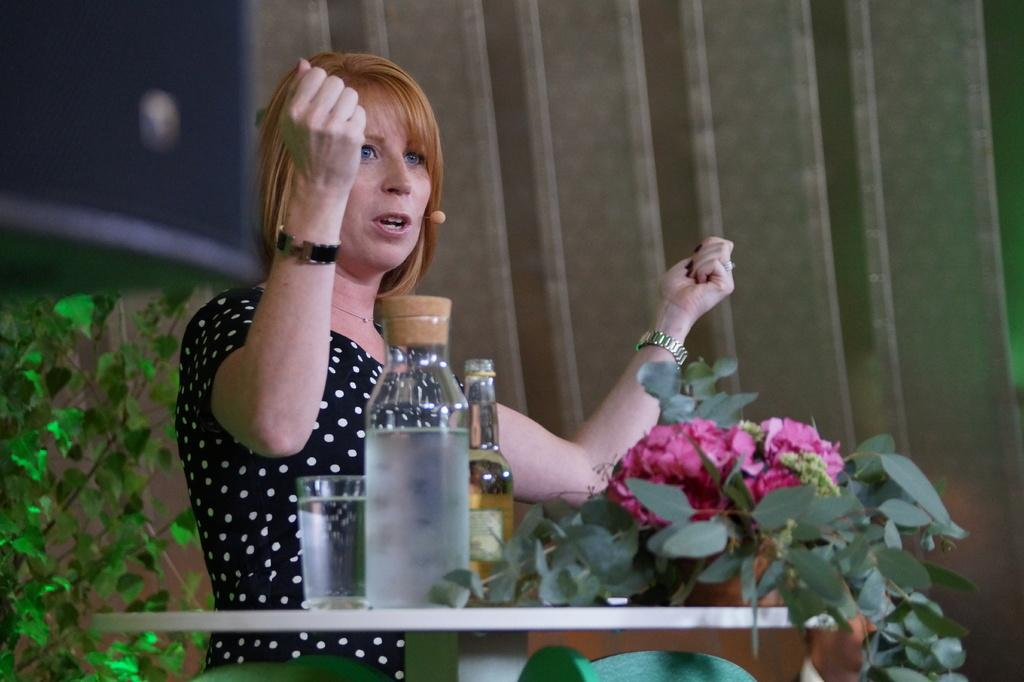Who is the main subject in the image? There is a woman in the image. What is the woman doing in the image? The woman is standing and talking in front of a mic. What objects can be seen on the table in the image? There are bottles, a plant, and a glass of water on the table. What type of guitar is the woman playing in the image? There is no guitar present in the image; the woman is talking in front of a mic. 